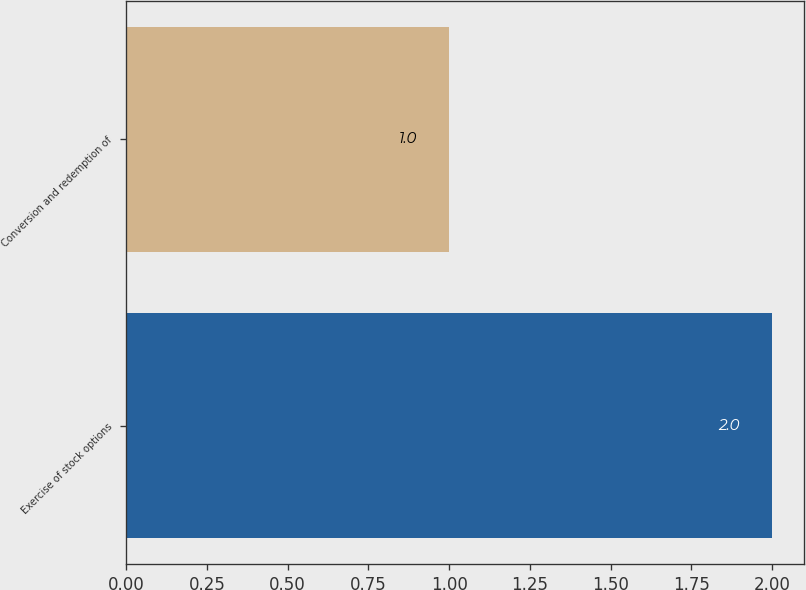Convert chart to OTSL. <chart><loc_0><loc_0><loc_500><loc_500><bar_chart><fcel>Exercise of stock options<fcel>Conversion and redemption of<nl><fcel>2<fcel>1<nl></chart> 